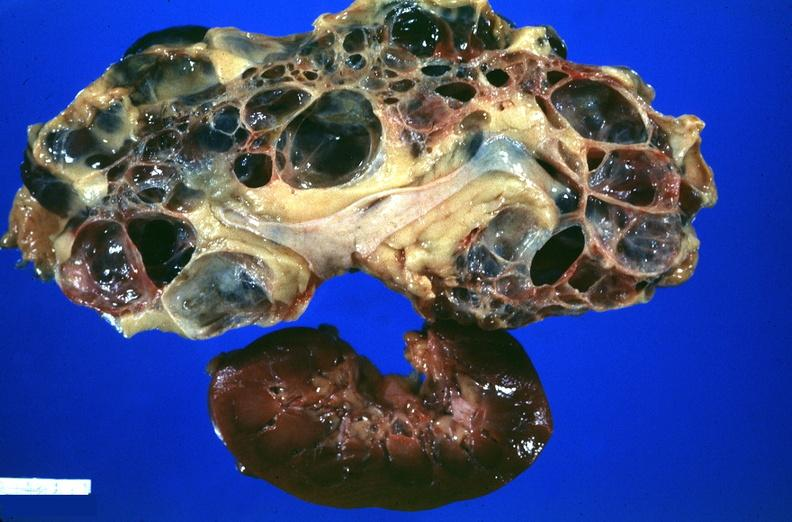what does this image show?
Answer the question using a single word or phrase. Kidney 